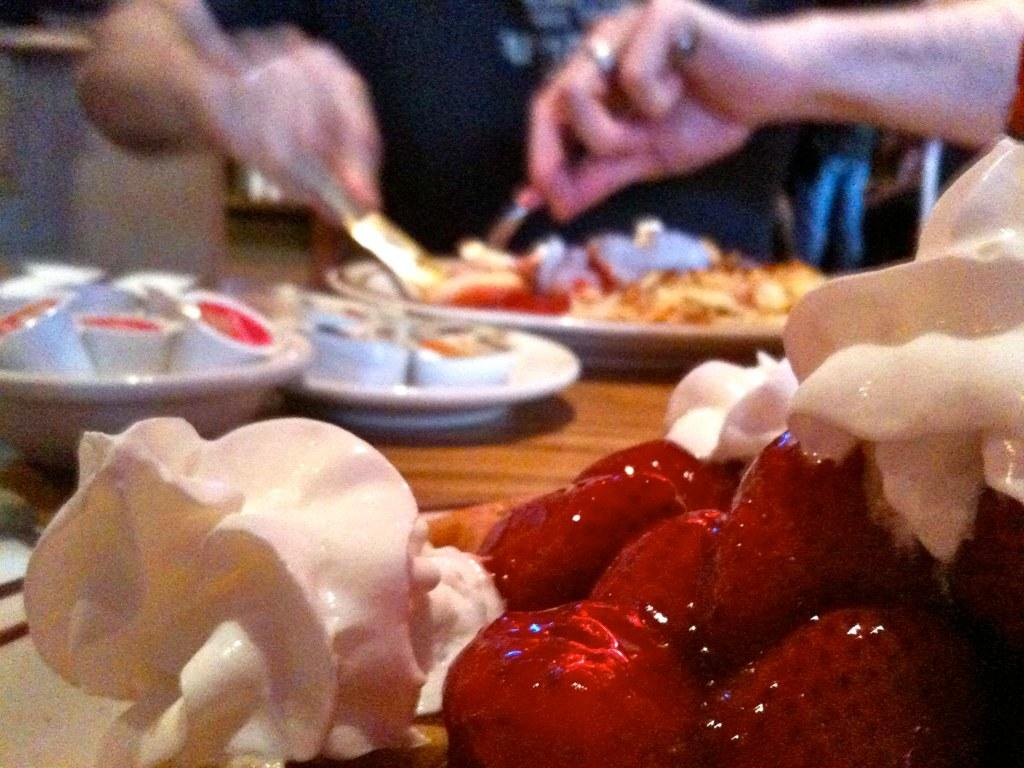What is the main object in the center of the image? There is a table in the center of the image. What is on the table? The table contains strawberries and other food items. Who is present in the image? There is a man in the image. What is the man doing? The man is eating. Where is the man located in the image? The man is located at the top side of the image. What type of vessel can be seen sailing in the sky in the image? There is no vessel sailing in the sky in the image; it only features a table with food items and a man eating. What kind of cloud is present in the image? There are no clouds present in the image; it only features a table with food items, a man eating, and the man's location. 